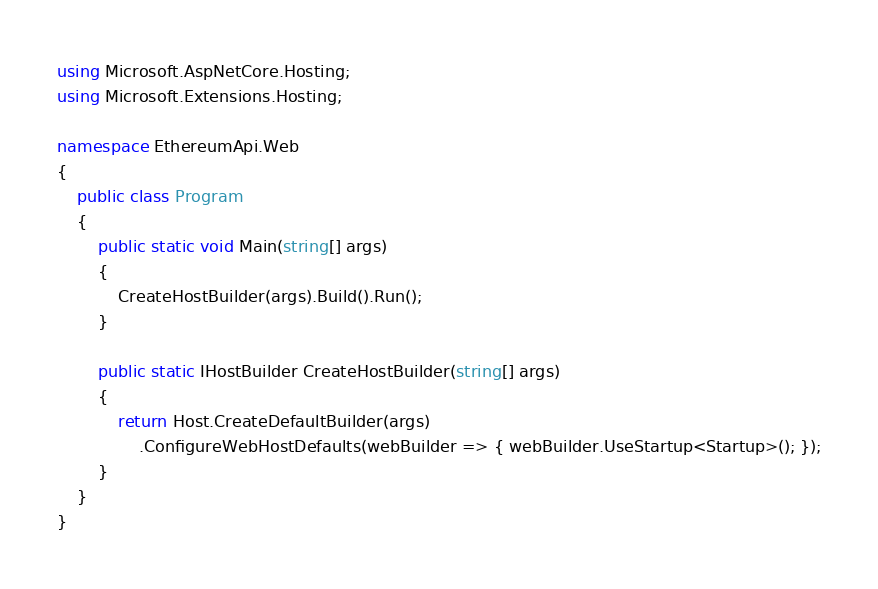Convert code to text. <code><loc_0><loc_0><loc_500><loc_500><_C#_>using Microsoft.AspNetCore.Hosting;
using Microsoft.Extensions.Hosting;

namespace EthereumApi.Web
{
    public class Program
    {
        public static void Main(string[] args)
        {
            CreateHostBuilder(args).Build().Run();
        }

        public static IHostBuilder CreateHostBuilder(string[] args)
        {
            return Host.CreateDefaultBuilder(args)
                .ConfigureWebHostDefaults(webBuilder => { webBuilder.UseStartup<Startup>(); });
        }
    }
}</code> 